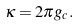Convert formula to latex. <formula><loc_0><loc_0><loc_500><loc_500>\kappa = 2 \pi g _ { c } .</formula> 